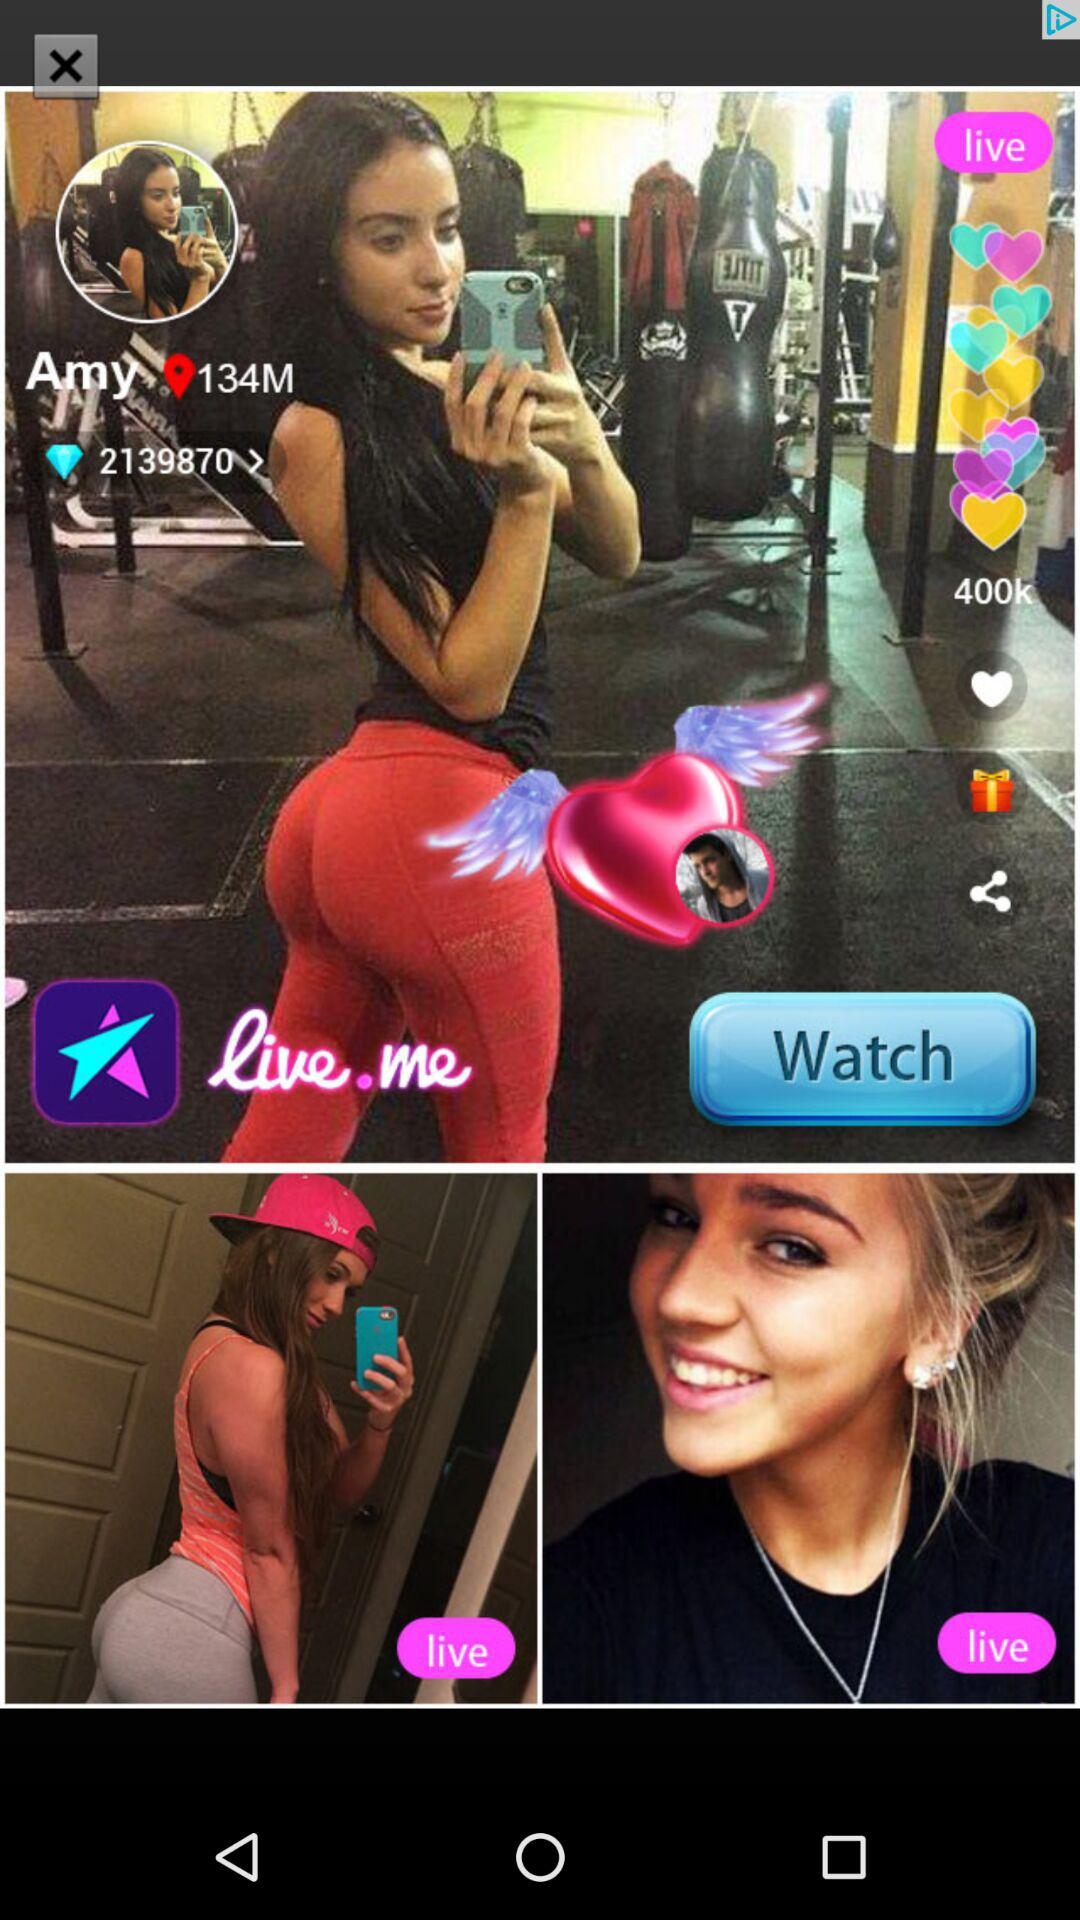What is the name? The name is Amy. 